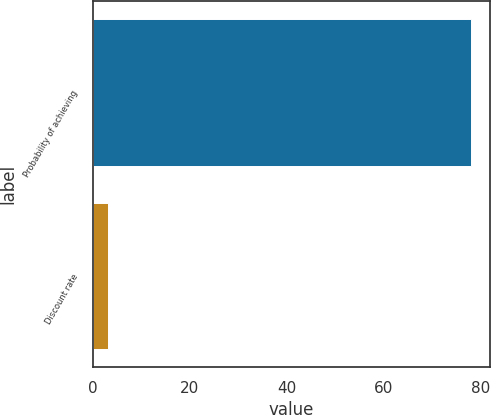Convert chart to OTSL. <chart><loc_0><loc_0><loc_500><loc_500><bar_chart><fcel>Probability of achieving<fcel>Discount rate<nl><fcel>78.1<fcel>3<nl></chart> 